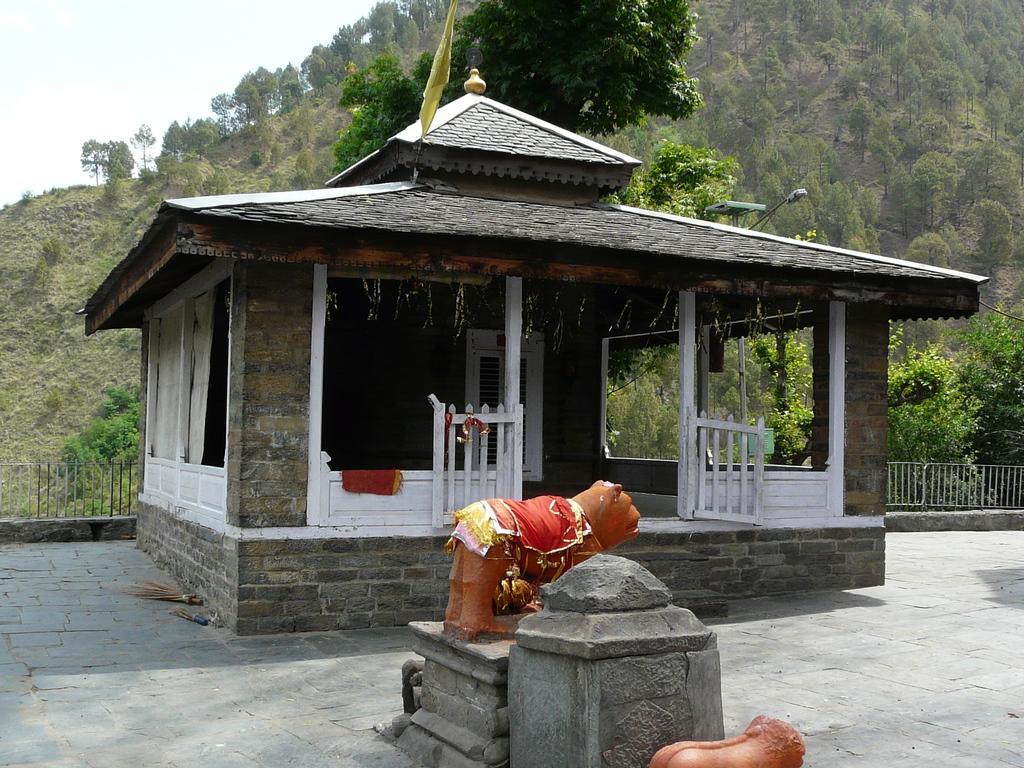Describe this image in one or two sentences. In the center of the image we can see a shed. At the bottom there are sculptures and we can see stones. In the background there is a fence, trees and sky. 